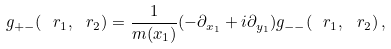Convert formula to latex. <formula><loc_0><loc_0><loc_500><loc_500>g _ { + - } ( \ r _ { 1 } , \ r _ { 2 } ) = \frac { 1 } { m ( x _ { 1 } ) } ( - \partial _ { x _ { 1 } } + i \partial _ { y _ { 1 } } ) g _ { - - } ( \ r _ { 1 } , \ r _ { 2 } ) \, ,</formula> 